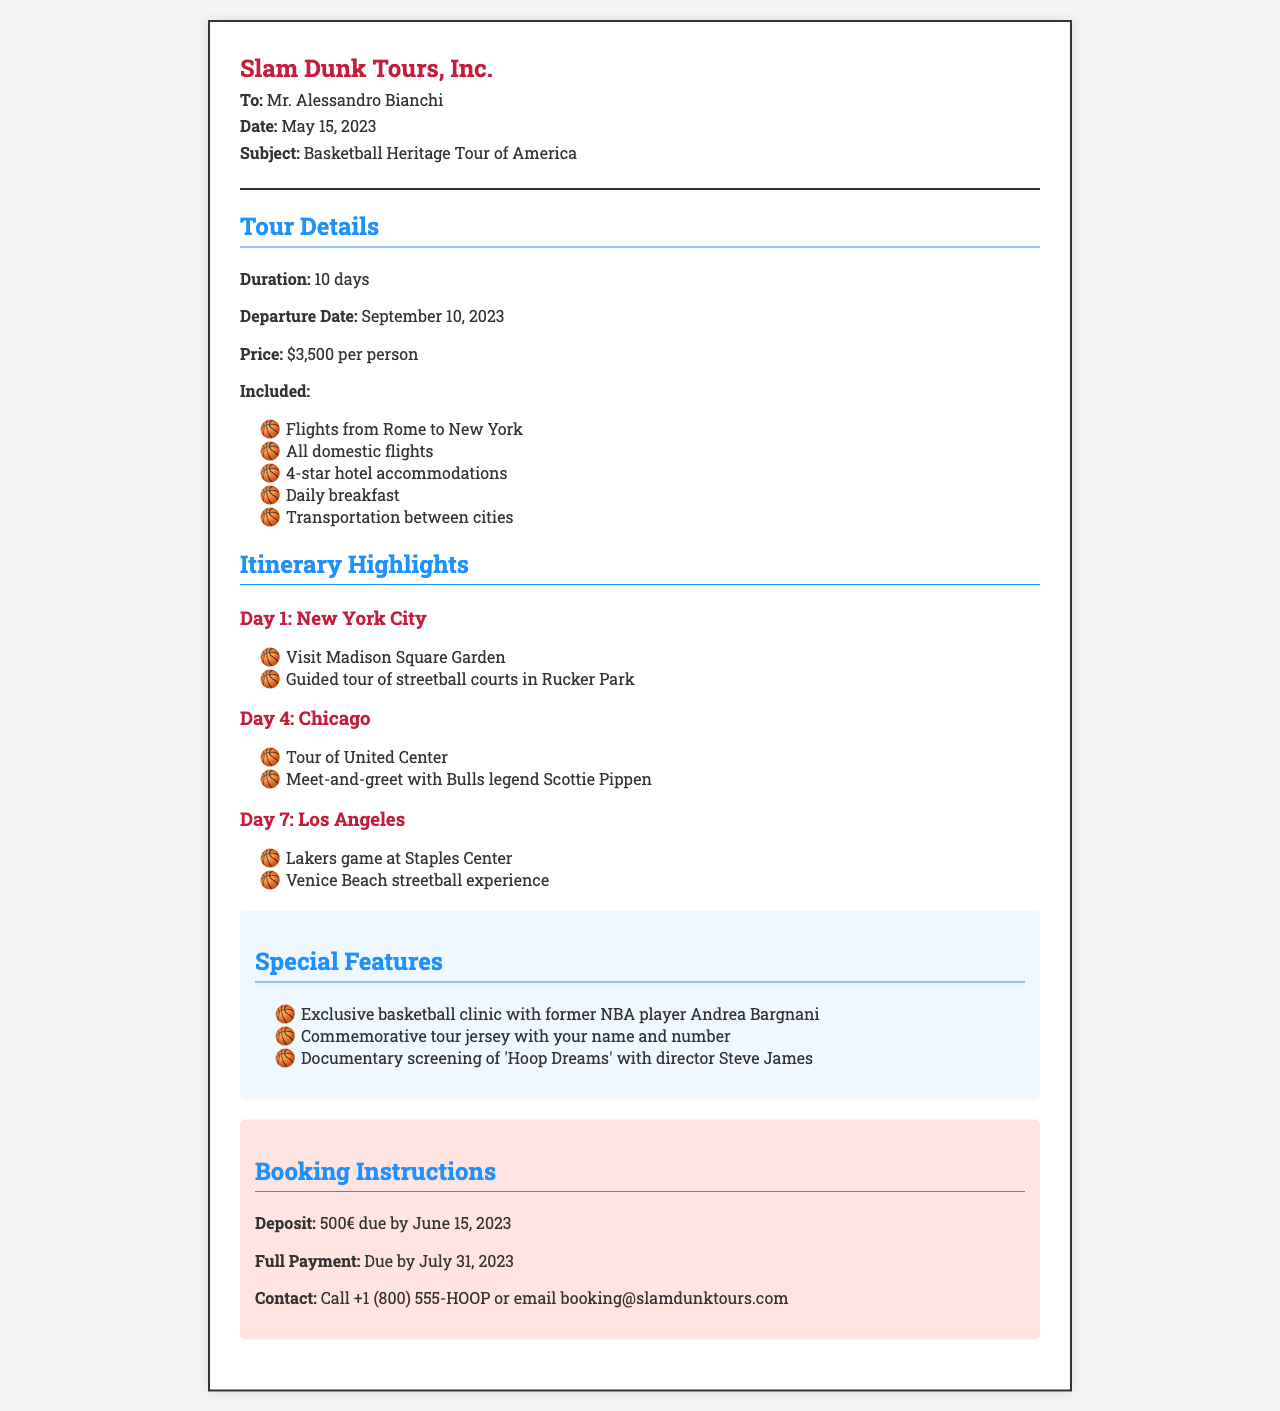What is the duration of the tour? The duration of the tour is explicitly mentioned in the document as 10 days.
Answer: 10 days What is the departure date? The document specifies the departure date as September 10, 2023.
Answer: September 10, 2023 What is included in the tour package? The document lists several inclusions such as flights, hotel accommodations, and transportation; the first item mentioned is flights from Rome to New York.
Answer: Flights from Rome to New York Who will participants meet in Chicago? The document states that participants will have a meet-and-greet with Bulls legend Scottie Pippen on Day 4.
Answer: Scottie Pippen What is the deposit amount required for booking? The necessary deposit for booking is indicated in the document as 500€ due by June 15, 2023.
Answer: 500€ What is one special feature of the tour? The document mentions several special features, one of which is an exclusive basketball clinic with former NBA player Andrea Bargnani.
Answer: Exclusive basketball clinic with Andrea Bargnani How many nights will participants stay in hotels? Participants will stay for 9 nights as the tour is 10 days long.
Answer: 9 nights What is the contact email for booking? The email provided for booking inquiries is stated as booking@slamdunktours.com in the document.
Answer: booking@slamdunktours.com 